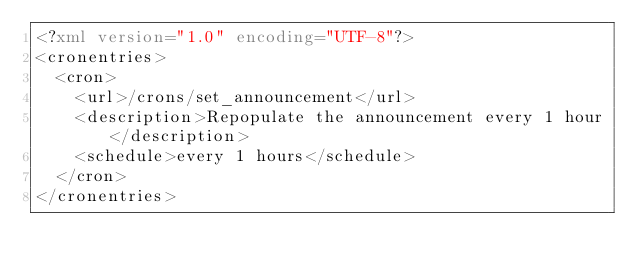Convert code to text. <code><loc_0><loc_0><loc_500><loc_500><_XML_><?xml version="1.0" encoding="UTF-8"?>
<cronentries>
  <cron>
    <url>/crons/set_announcement</url>
    <description>Repopulate the announcement every 1 hour</description>
    <schedule>every 1 hours</schedule>
  </cron>  
</cronentries></code> 